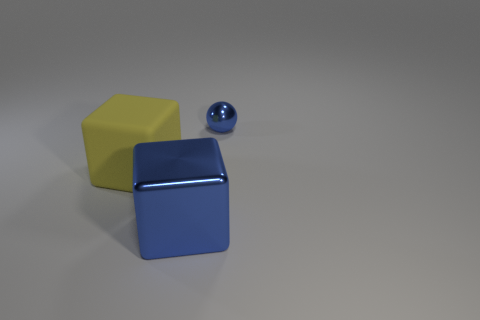Is there any other thing that is the same size as the blue metallic ball?
Your answer should be very brief. No. How many rubber blocks are left of the blue metal sphere?
Make the answer very short. 1. There is a blue metallic object that is behind the metal thing in front of the small blue thing; what is its shape?
Offer a very short reply. Sphere. Is there anything else that is the same shape as the tiny blue thing?
Your answer should be very brief. No. Is the number of blue shiny objects that are behind the blue shiny cube greater than the number of large gray cubes?
Offer a terse response. Yes. How many objects are in front of the metal thing behind the large blue metallic block?
Offer a very short reply. 2. There is a blue metal thing in front of the blue metal thing that is behind the blue metallic object that is on the left side of the blue metallic ball; what is its shape?
Your answer should be compact. Cube. The metal ball is what size?
Offer a very short reply. Small. Is there a cube that has the same material as the small blue ball?
Provide a short and direct response. Yes. Are there the same number of yellow cubes that are behind the small blue shiny ball and yellow metallic things?
Provide a succinct answer. Yes. 